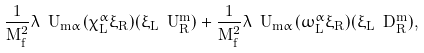<formula> <loc_0><loc_0><loc_500><loc_500>\frac { 1 } { M _ { f } ^ { 2 } } \lambda ^ { \ } U _ { \bar { m } \alpha } ( \bar { \chi } _ { L } ^ { \alpha } \xi _ { R } ) ( \bar { \xi } _ { L } \ U _ { R } ^ { \bar { m } } ) + \frac { 1 } { M _ { f } ^ { 2 } } \lambda ^ { \ } U _ { \bar { m } \alpha } ( \bar { \omega } _ { L } ^ { \alpha } \xi _ { R } ) ( \bar { \xi } _ { L } \ D _ { R } ^ { \bar { m } } ) ,</formula> 